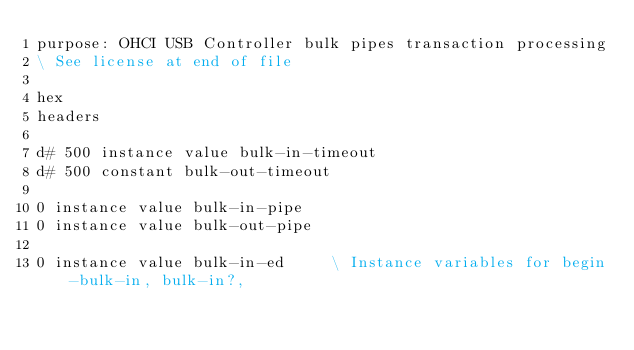Convert code to text. <code><loc_0><loc_0><loc_500><loc_500><_Forth_>purpose: OHCI USB Controller bulk pipes transaction processing
\ See license at end of file

hex
headers

d# 500 instance value bulk-in-timeout
d# 500 constant bulk-out-timeout

0 instance value bulk-in-pipe
0 instance value bulk-out-pipe

0 instance value bulk-in-ed		\ Instance variables for begin-bulk-in, bulk-in?,</code> 